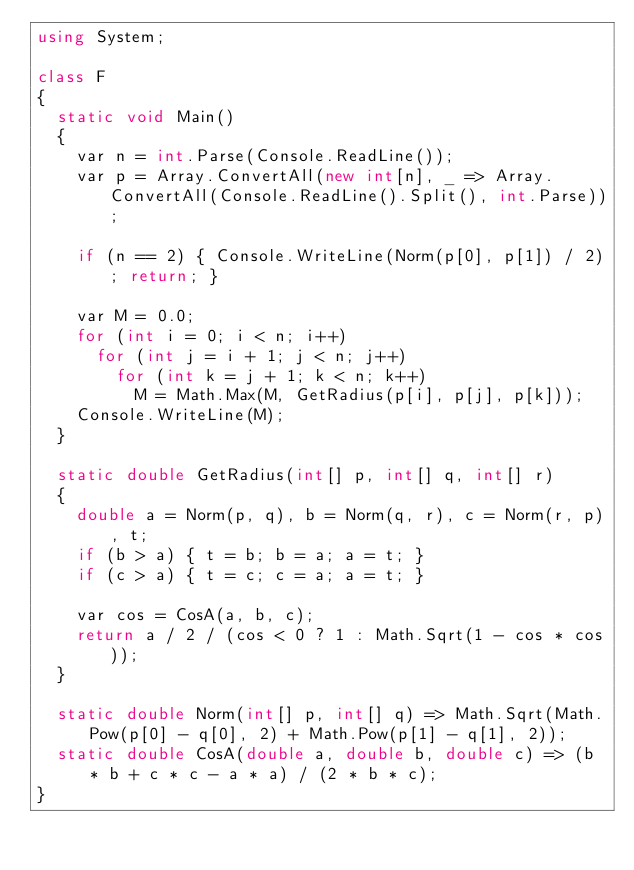<code> <loc_0><loc_0><loc_500><loc_500><_C#_>using System;

class F
{
	static void Main()
	{
		var n = int.Parse(Console.ReadLine());
		var p = Array.ConvertAll(new int[n], _ => Array.ConvertAll(Console.ReadLine().Split(), int.Parse));

		if (n == 2) { Console.WriteLine(Norm(p[0], p[1]) / 2); return; }

		var M = 0.0;
		for (int i = 0; i < n; i++)
			for (int j = i + 1; j < n; j++)
				for (int k = j + 1; k < n; k++)
					M = Math.Max(M, GetRadius(p[i], p[j], p[k]));
		Console.WriteLine(M);
	}

	static double GetRadius(int[] p, int[] q, int[] r)
	{
		double a = Norm(p, q), b = Norm(q, r), c = Norm(r, p), t;
		if (b > a) { t = b; b = a; a = t; }
		if (c > a) { t = c; c = a; a = t; }

		var cos = CosA(a, b, c);
		return a / 2 / (cos < 0 ? 1 : Math.Sqrt(1 - cos * cos));
	}

	static double Norm(int[] p, int[] q) => Math.Sqrt(Math.Pow(p[0] - q[0], 2) + Math.Pow(p[1] - q[1], 2));
	static double CosA(double a, double b, double c) => (b * b + c * c - a * a) / (2 * b * c);
}
</code> 